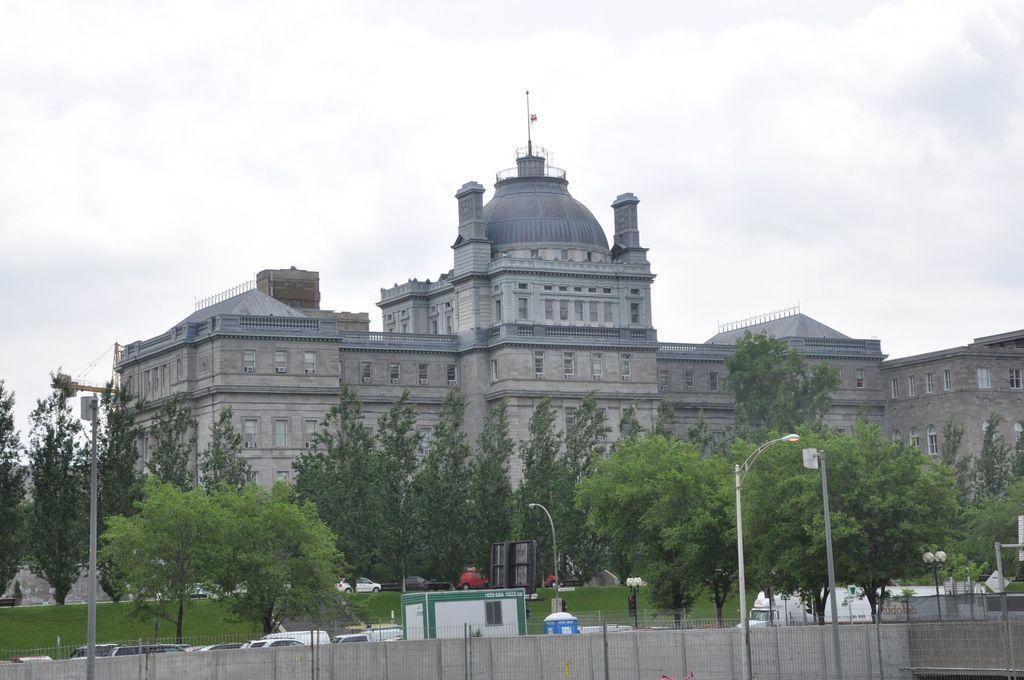Can you describe this image briefly? In this image I can see few poles, few street lights, number of vehicles, grass ground, number of trees and the wall in the front. I can also see a blue color thing in the center. In the background I can see a building, number of windows, clouds and the sky. 